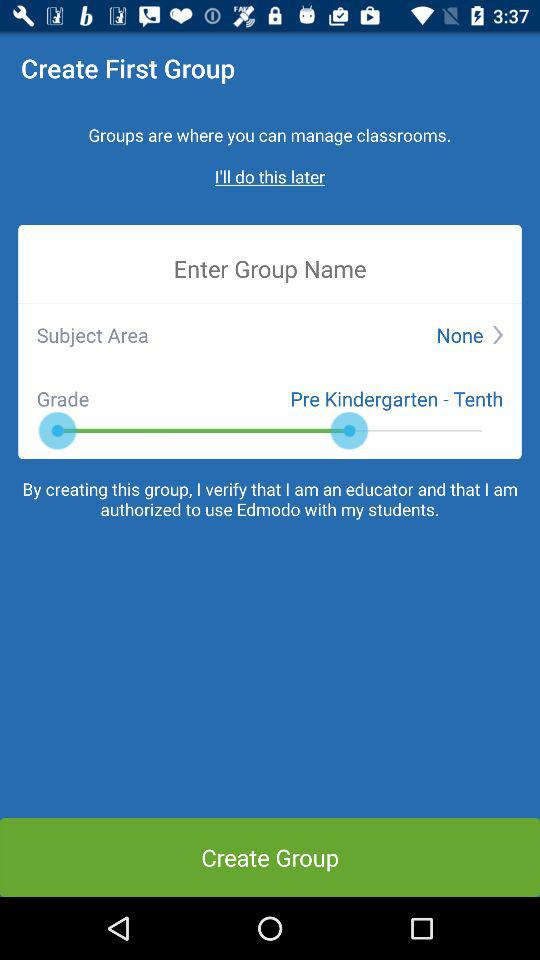What is "Grade"? "Grade" is "Pre Kindergarten - Tenth". 